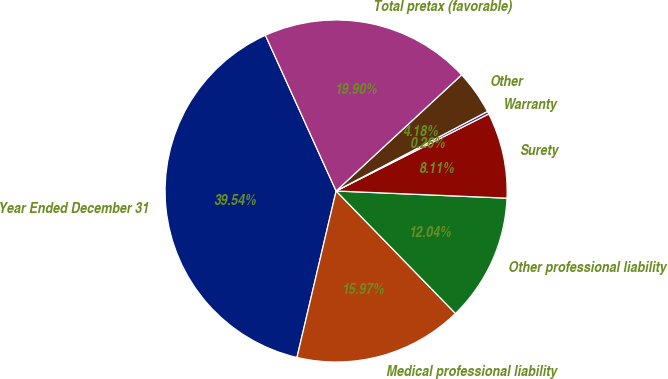Convert chart to OTSL. <chart><loc_0><loc_0><loc_500><loc_500><pie_chart><fcel>Year Ended December 31<fcel>Medical professional liability<fcel>Other professional liability<fcel>Surety<fcel>Warranty<fcel>Other<fcel>Total pretax (favorable)<nl><fcel>39.54%<fcel>15.97%<fcel>12.04%<fcel>8.11%<fcel>0.26%<fcel>4.18%<fcel>19.9%<nl></chart> 